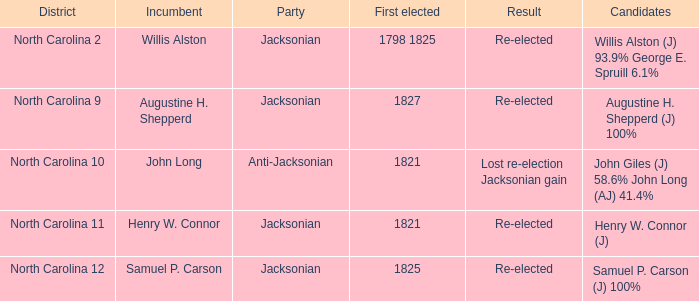9% and george e. spruill 1.0. 